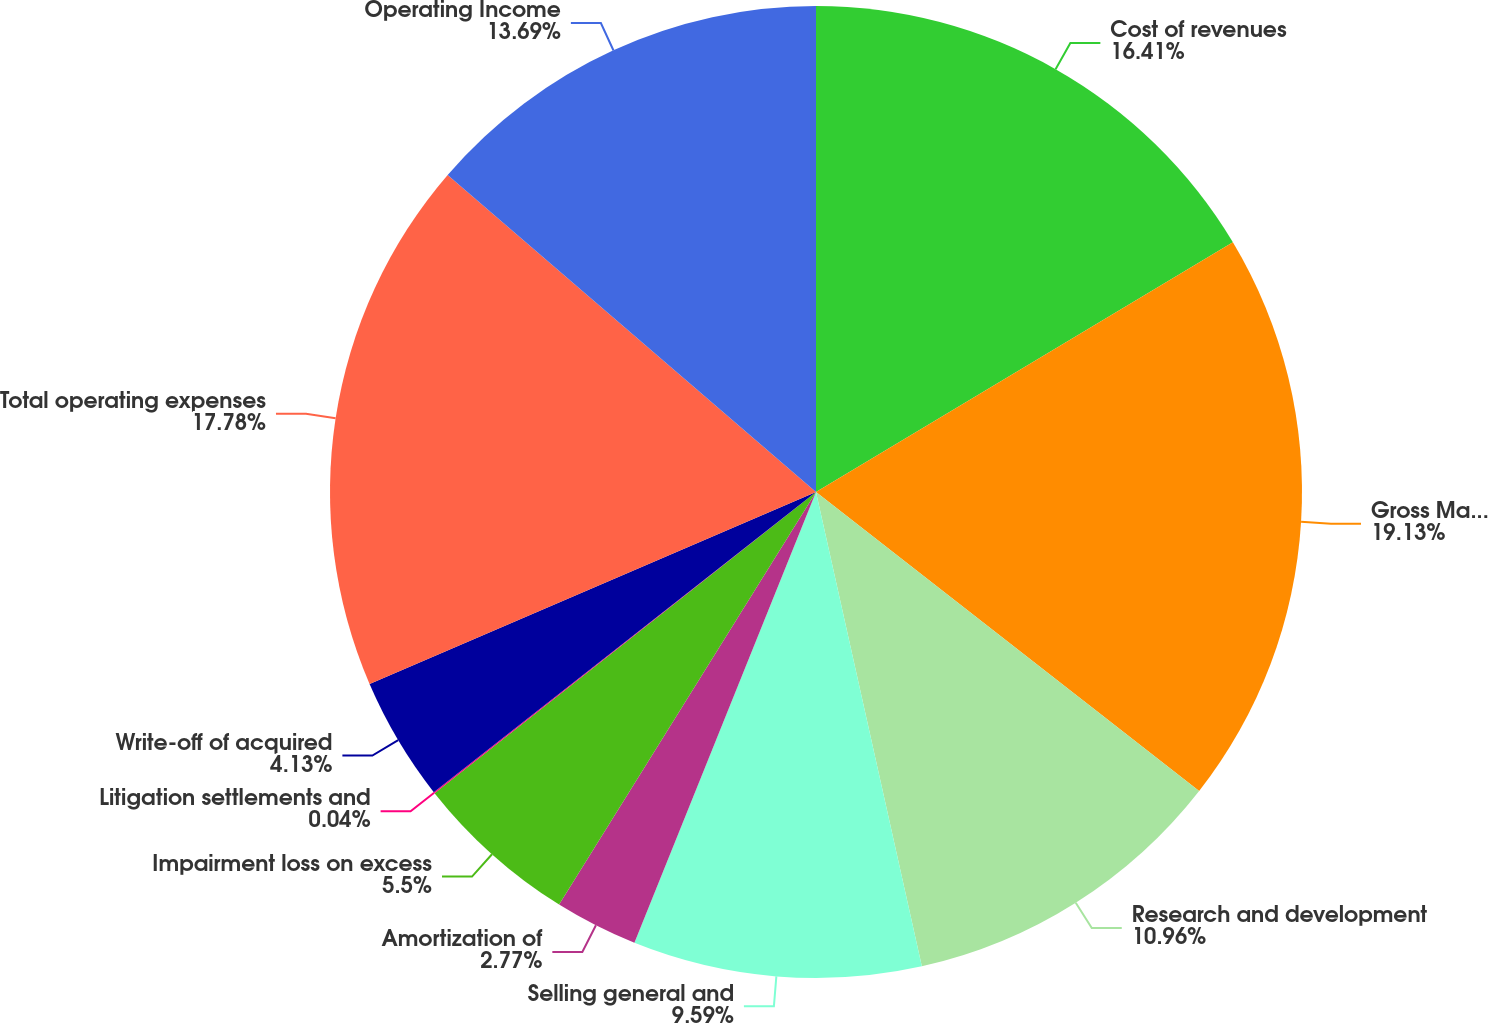<chart> <loc_0><loc_0><loc_500><loc_500><pie_chart><fcel>Cost of revenues<fcel>Gross Margin<fcel>Research and development<fcel>Selling general and<fcel>Amortization of<fcel>Impairment loss on excess<fcel>Litigation settlements and<fcel>Write-off of acquired<fcel>Total operating expenses<fcel>Operating Income<nl><fcel>16.41%<fcel>19.14%<fcel>10.96%<fcel>9.59%<fcel>2.77%<fcel>5.5%<fcel>0.04%<fcel>4.13%<fcel>17.78%<fcel>13.69%<nl></chart> 